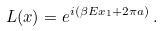<formula> <loc_0><loc_0><loc_500><loc_500>L ( x ) = e ^ { i ( \beta E x _ { 1 } + 2 \pi a ) } \, .</formula> 